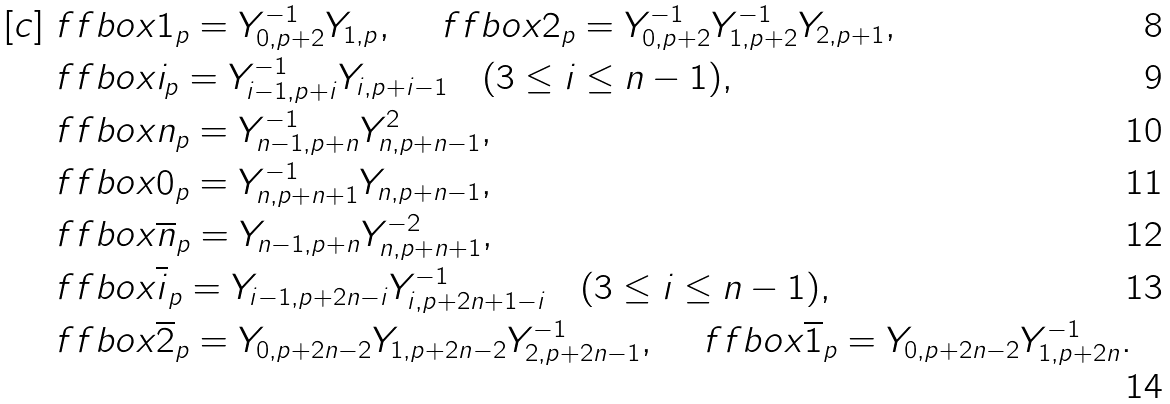Convert formula to latex. <formula><loc_0><loc_0><loc_500><loc_500>[ c ] & \ f f b o x { 1 } _ { p } = Y _ { 0 , p + 2 } ^ { - 1 } Y _ { 1 , p } , \quad \ f f b o x { 2 } _ { p } = Y _ { 0 , p + 2 } ^ { - 1 } Y _ { 1 , p + 2 } ^ { - 1 } Y _ { 2 , p + 1 } , \\ & \ f f b o x { i } _ { p } = Y _ { i - 1 , p + i } ^ { - 1 } Y _ { i , p + { i - 1 } } \quad ( 3 \leq i \leq n - 1 ) , \\ & \ f f b o x { n } _ { p } = Y _ { n - 1 , p + n } ^ { - 1 } Y _ { n , p + { n - 1 } } ^ { 2 } , \\ & \ f f b o x { 0 } _ { p } = Y _ { n , p + { n } + 1 } ^ { - 1 } Y _ { n , p + { n - 1 } } , \\ & \ f f b o x { \overline { n } } _ { p } = Y _ { n - 1 , p + n } Y _ { n , p + { n } + 1 } ^ { - 2 } , \\ & \ f f b o x { \overline { i } } _ { p } = Y _ { i - 1 , p + { 2 n - i } } Y _ { i , p + { 2 n + 1 - i } } ^ { - 1 } \quad ( 3 \leq i \leq n - 1 ) , \\ & \ f f b o x { \overline { 2 } } _ { p } = Y _ { 0 , p + 2 n - 2 } Y _ { 1 , p + 2 n - 2 } Y _ { 2 , p + 2 n - 1 } ^ { - 1 } , \quad \ f f b o x { \overline { 1 } } _ { p } = Y _ { 0 , p + 2 n - 2 } Y _ { 1 , p + { 2 n } } ^ { - 1 } .</formula> 